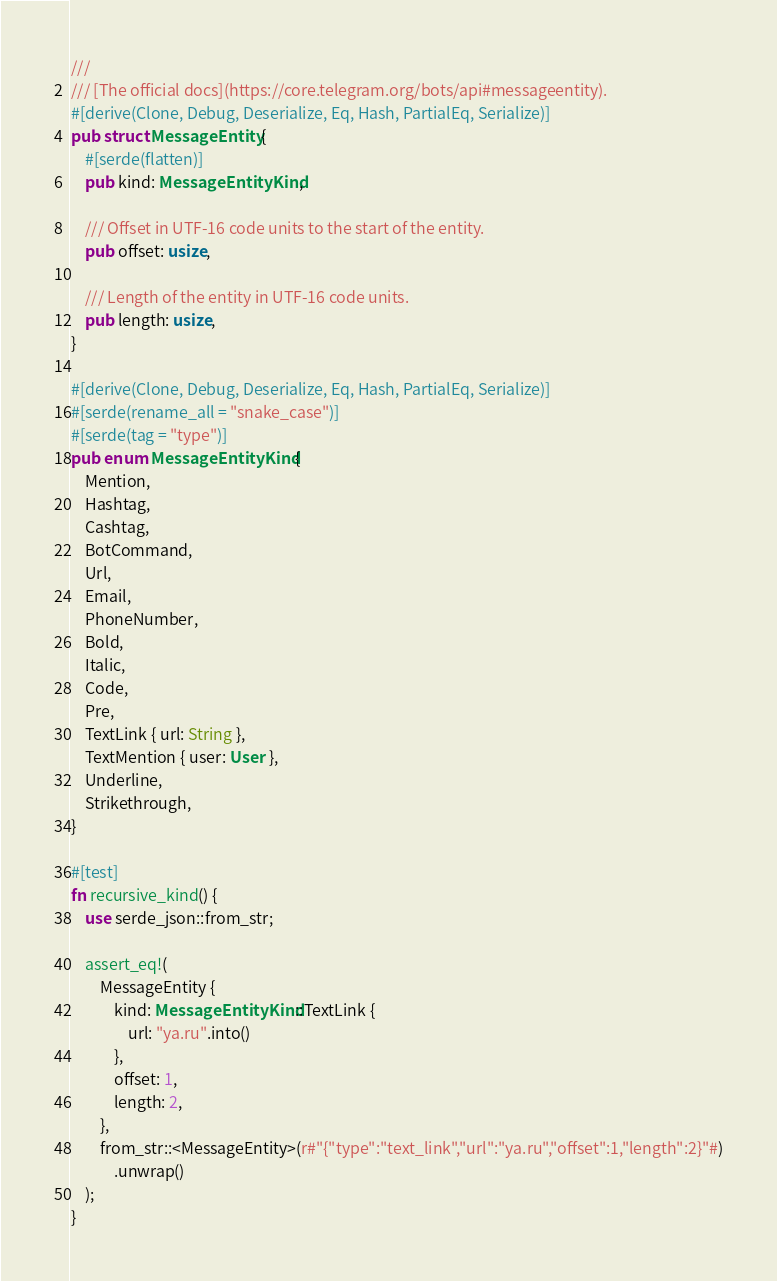Convert code to text. <code><loc_0><loc_0><loc_500><loc_500><_Rust_>///
/// [The official docs](https://core.telegram.org/bots/api#messageentity).
#[derive(Clone, Debug, Deserialize, Eq, Hash, PartialEq, Serialize)]
pub struct MessageEntity {
    #[serde(flatten)]
    pub kind: MessageEntityKind,

    /// Offset in UTF-16 code units to the start of the entity.
    pub offset: usize,

    /// Length of the entity in UTF-16 code units.
    pub length: usize,
}

#[derive(Clone, Debug, Deserialize, Eq, Hash, PartialEq, Serialize)]
#[serde(rename_all = "snake_case")]
#[serde(tag = "type")]
pub enum MessageEntityKind {
    Mention,
    Hashtag,
    Cashtag,
    BotCommand,
    Url,
    Email,
    PhoneNumber,
    Bold,
    Italic,
    Code,
    Pre,
    TextLink { url: String },
    TextMention { user: User },
    Underline,
    Strikethrough,
}

#[test]
fn recursive_kind() {
    use serde_json::from_str;

    assert_eq!(
        MessageEntity {
            kind: MessageEntityKind::TextLink {
                url: "ya.ru".into()
            },
            offset: 1,
            length: 2,
        },
        from_str::<MessageEntity>(r#"{"type":"text_link","url":"ya.ru","offset":1,"length":2}"#)
            .unwrap()
    );
}
</code> 